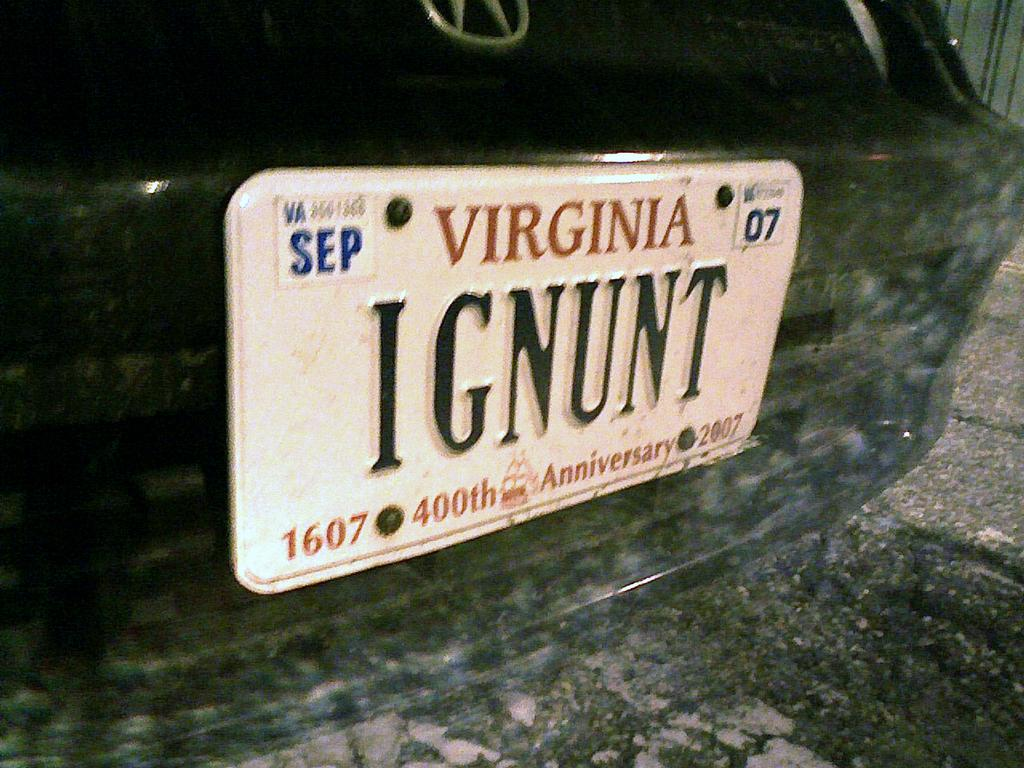<image>
Render a clear and concise summary of the photo. A Virginia license plate says "IGNUNT" and the year 2007 on it. 